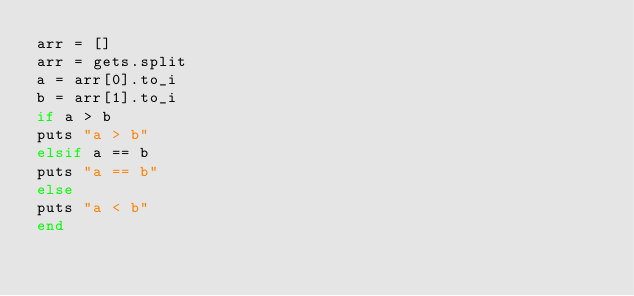<code> <loc_0><loc_0><loc_500><loc_500><_Ruby_>arr = []
arr = gets.split
a = arr[0].to_i
b = arr[1].to_i
if a > b
puts "a > b"
elsif a == b
puts "a == b"
else
puts "a < b"
end</code> 